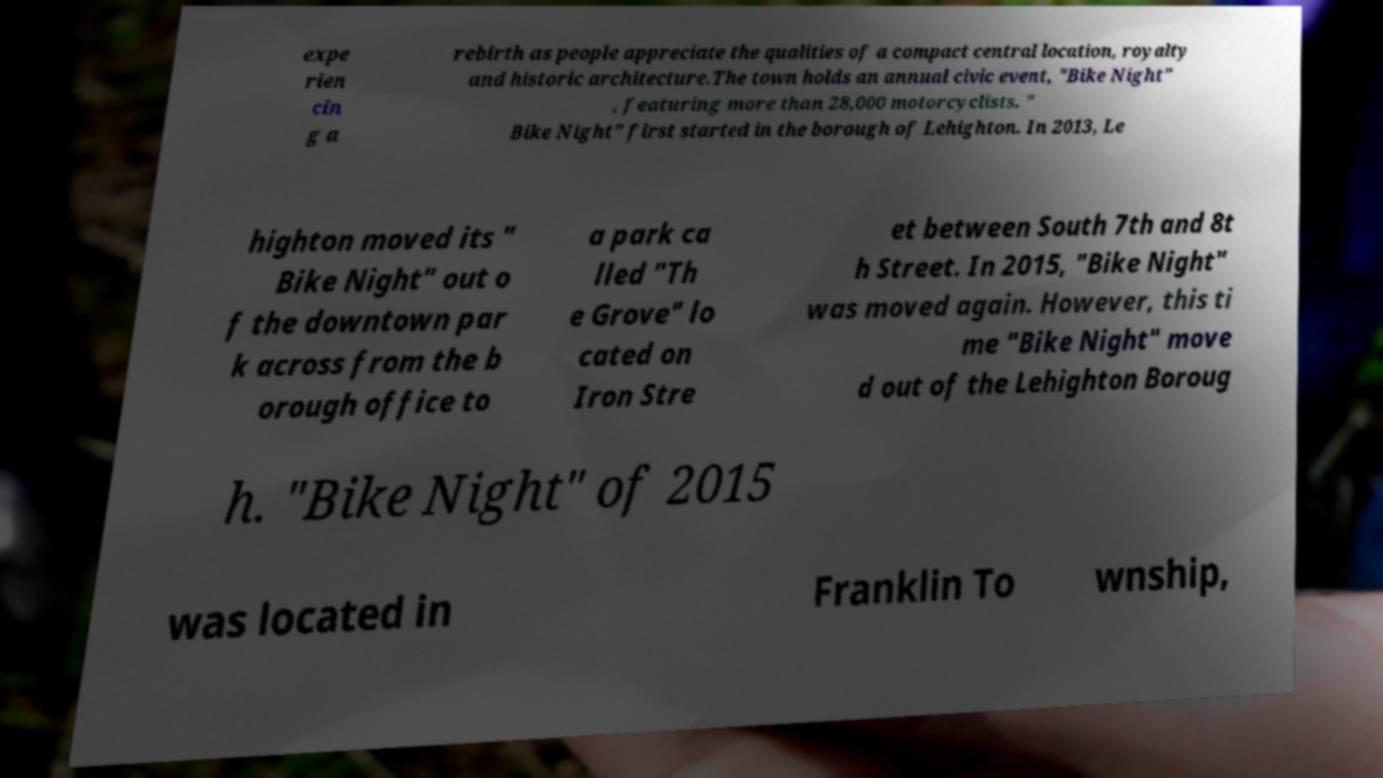Please read and relay the text visible in this image. What does it say? expe rien cin g a rebirth as people appreciate the qualities of a compact central location, royalty and historic architecture.The town holds an annual civic event, "Bike Night" , featuring more than 28,000 motorcyclists. " Bike Night" first started in the borough of Lehighton. In 2013, Le highton moved its " Bike Night" out o f the downtown par k across from the b orough office to a park ca lled "Th e Grove" lo cated on Iron Stre et between South 7th and 8t h Street. In 2015, "Bike Night" was moved again. However, this ti me "Bike Night" move d out of the Lehighton Boroug h. "Bike Night" of 2015 was located in Franklin To wnship, 